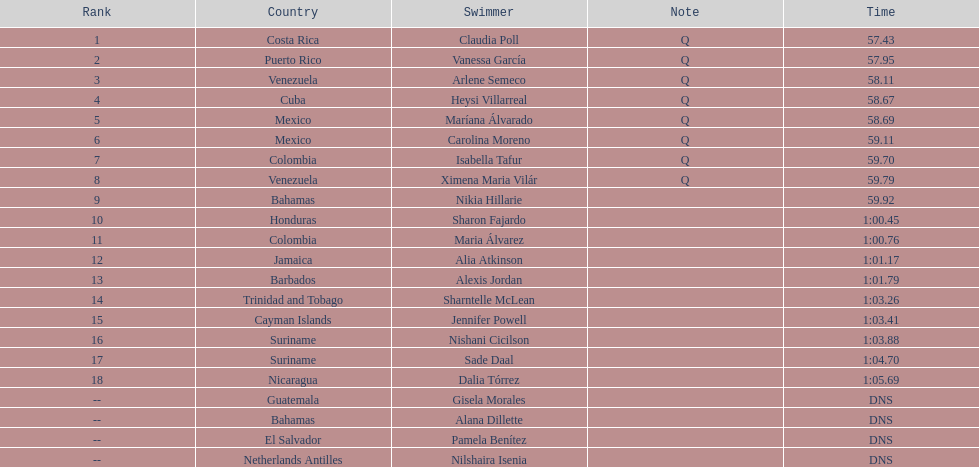What swimmer had the top or first rank? Claudia Poll. 